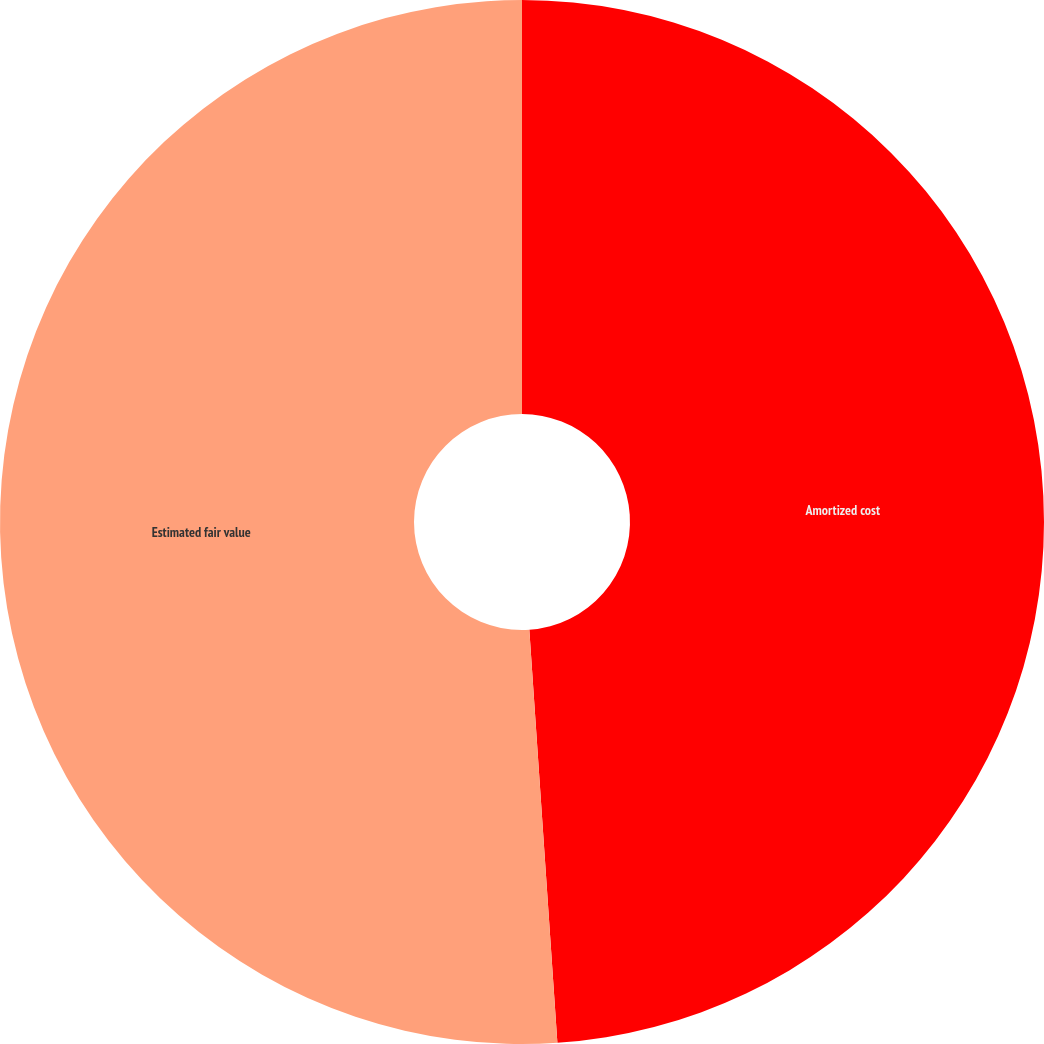Convert chart to OTSL. <chart><loc_0><loc_0><loc_500><loc_500><pie_chart><fcel>Amortized cost<fcel>Estimated fair value<nl><fcel>48.92%<fcel>51.08%<nl></chart> 